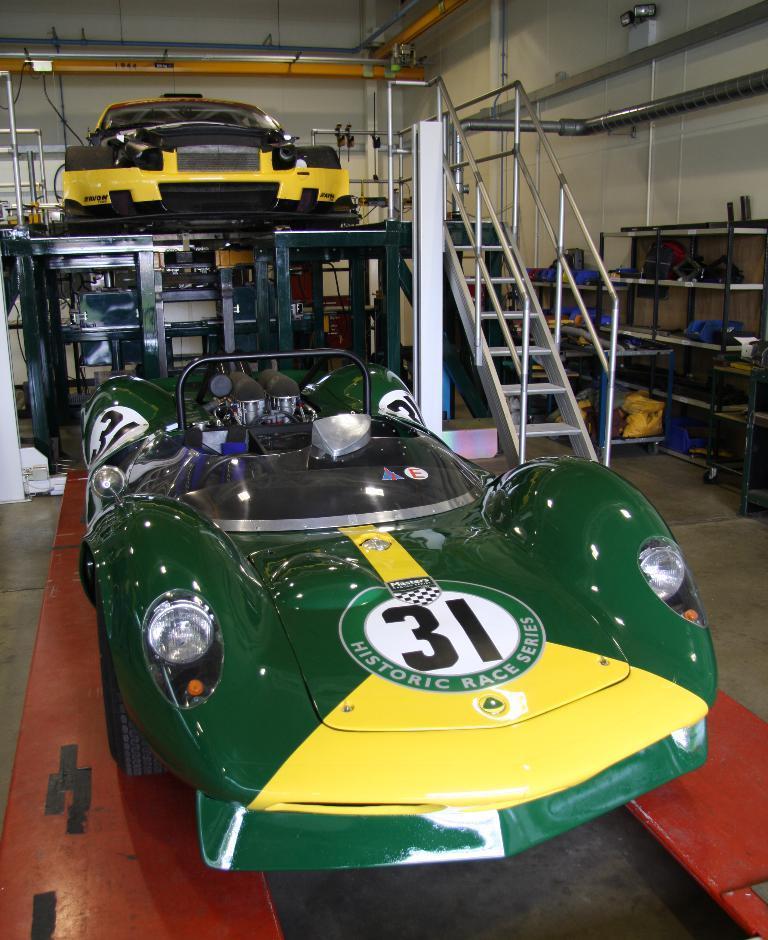Could you give a brief overview of what you see in this image? In the center of the image we can see vehicles. On the right there are stairs and we can see stands. In the background there is a wall and there are pipes. 